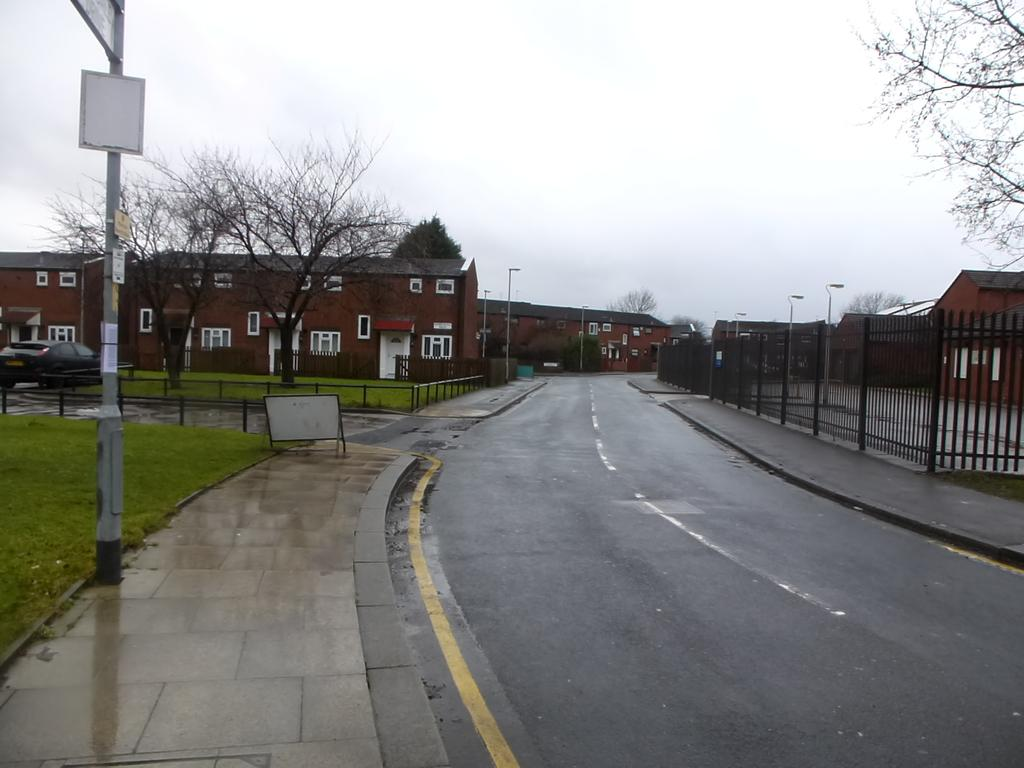What type of pathway can be seen in the image? There is a road in the image. What is located alongside the road? There is fencing and a pole in the image. What types of vehicles are present in the image? There are cars in the image. What structures can be seen in the image? There are buildings in the image. What type of vegetation is present in the image? There are trees in the image. What part of the natural environment is visible in the image? The sky is visible in the image, and clouds are present in the sky. How many pumpkins are sitting on the bikes in the image? There are no pumpkins or bikes present in the image. Can you describe the geese flying over the buildings in the image? There are no geese present in the image; only the road, fencing, pole, cars, buildings, trees, sky, and clouds are visible. 